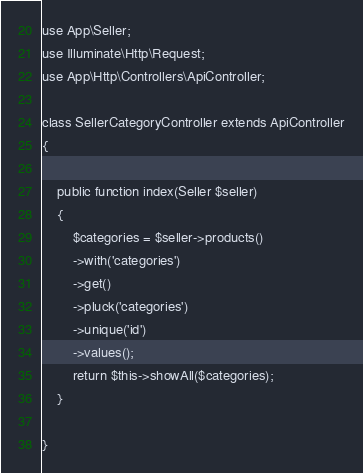<code> <loc_0><loc_0><loc_500><loc_500><_PHP_>
use App\Seller;
use Illuminate\Http\Request;
use App\Http\Controllers\ApiController;

class SellerCategoryController extends ApiController
{

    public function index(Seller $seller)
    {
        $categories = $seller->products()
        ->with('categories')
        ->get()
        ->pluck('categories')
        ->unique('id')
        ->values();
        return $this->showAll($categories);
    }

}
</code> 